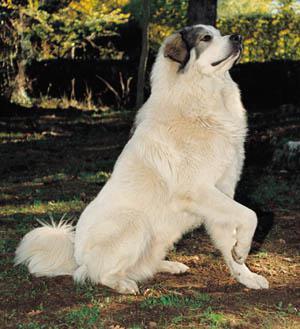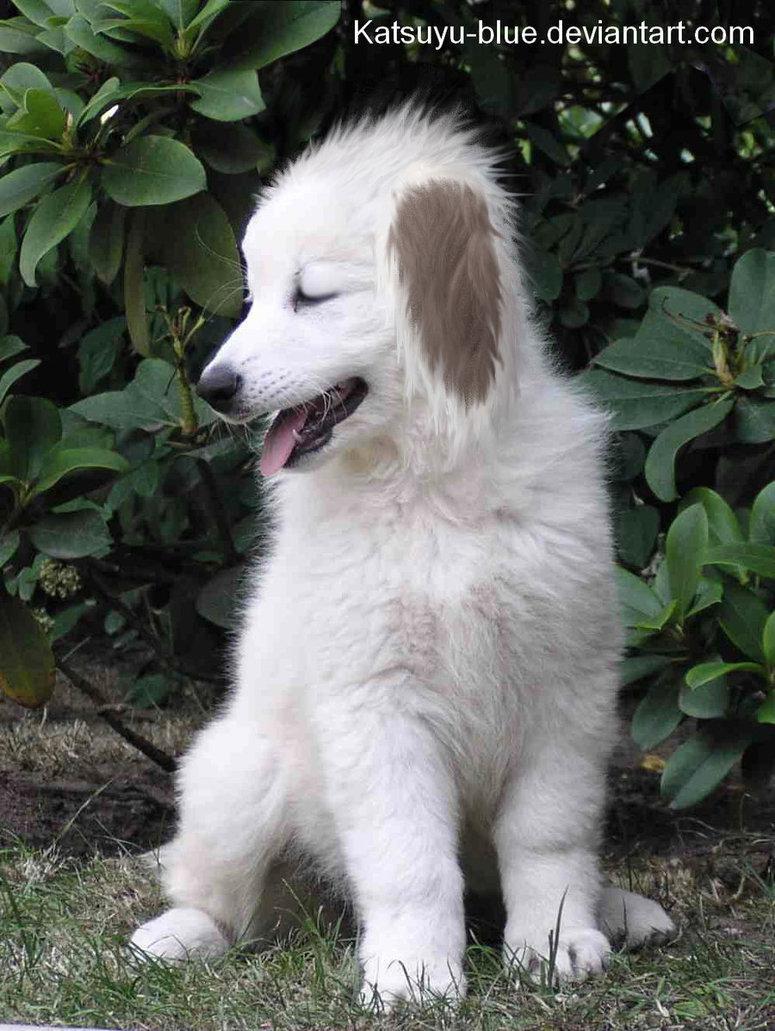The first image is the image on the left, the second image is the image on the right. Considering the images on both sides, is "There are at most two dogs." valid? Answer yes or no. Yes. The first image is the image on the left, the second image is the image on the right. Given the left and right images, does the statement "One image shows a single sitting white dog, and the other image contains multiple white dogs that are all puppies." hold true? Answer yes or no. No. 